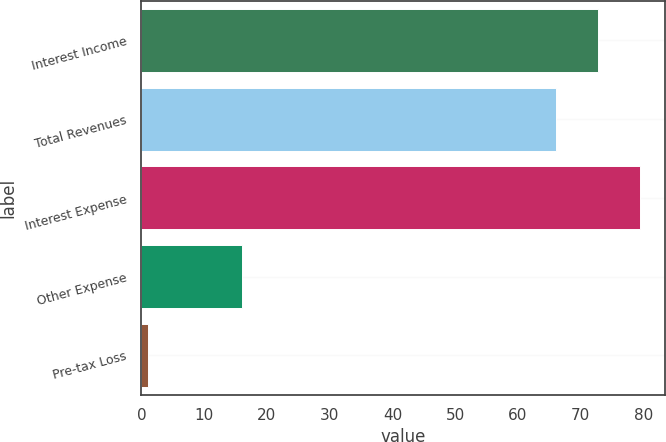<chart> <loc_0><loc_0><loc_500><loc_500><bar_chart><fcel>Interest Income<fcel>Total Revenues<fcel>Interest Expense<fcel>Other Expense<fcel>Pre-tax Loss<nl><fcel>72.7<fcel>66<fcel>79.4<fcel>16<fcel>1<nl></chart> 